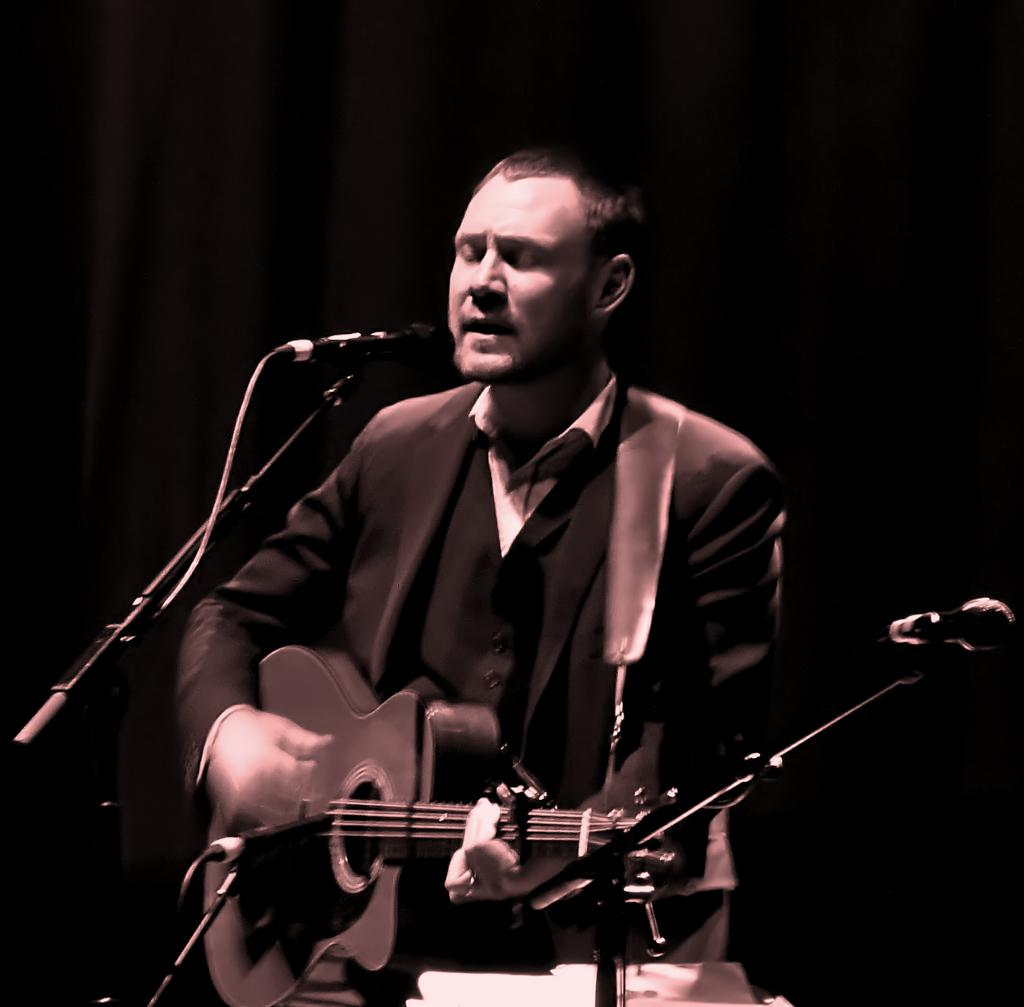What is the main subject of the image? The main subject of the image is a man. What is the man doing in the image? The man is sitting and playing a guitar. Is the man performing any vocal activity in the image? Yes, the man is singing into a microphone. What is the name of the nation that the man represents in the image? There is no indication of a specific nation or representation in the image. Who is the owner of the guitar that the man is playing? The image does not provide information about the ownership of the guitar. 